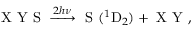Convert formula to latex. <formula><loc_0><loc_0><loc_500><loc_500>X Y S \xrightarrow { 2 h \nu } S ( ^ { 1 } D _ { 2 } ) + X Y ,</formula> 